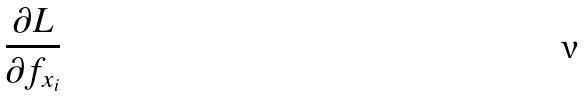<formula> <loc_0><loc_0><loc_500><loc_500>\frac { \partial L } { \partial f _ { x _ { i } } }</formula> 